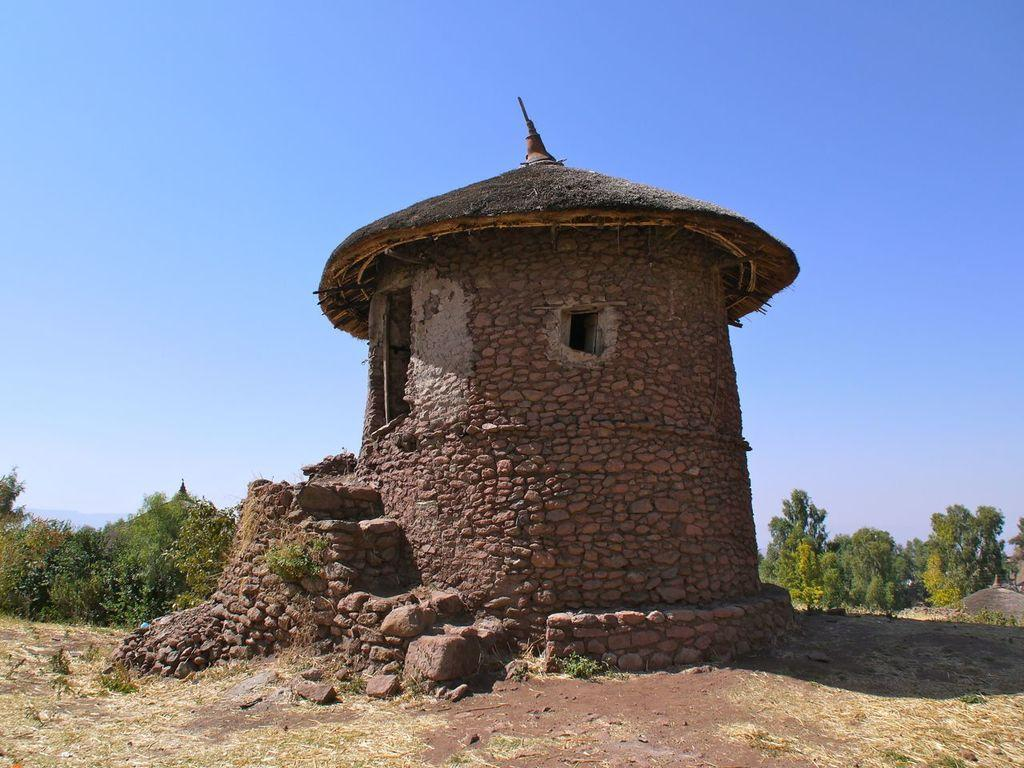What type of building is in the center of the image? There is a stone house in the center of the image. What can be seen in the background of the image? There are trees and the sky visible in the background of the image. What insect is playing on the door of the stone house in the image? There is no insect or door present in the image; it only features a stone house and the background elements. 